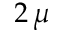Convert formula to latex. <formula><loc_0><loc_0><loc_500><loc_500>2 \, \mu</formula> 